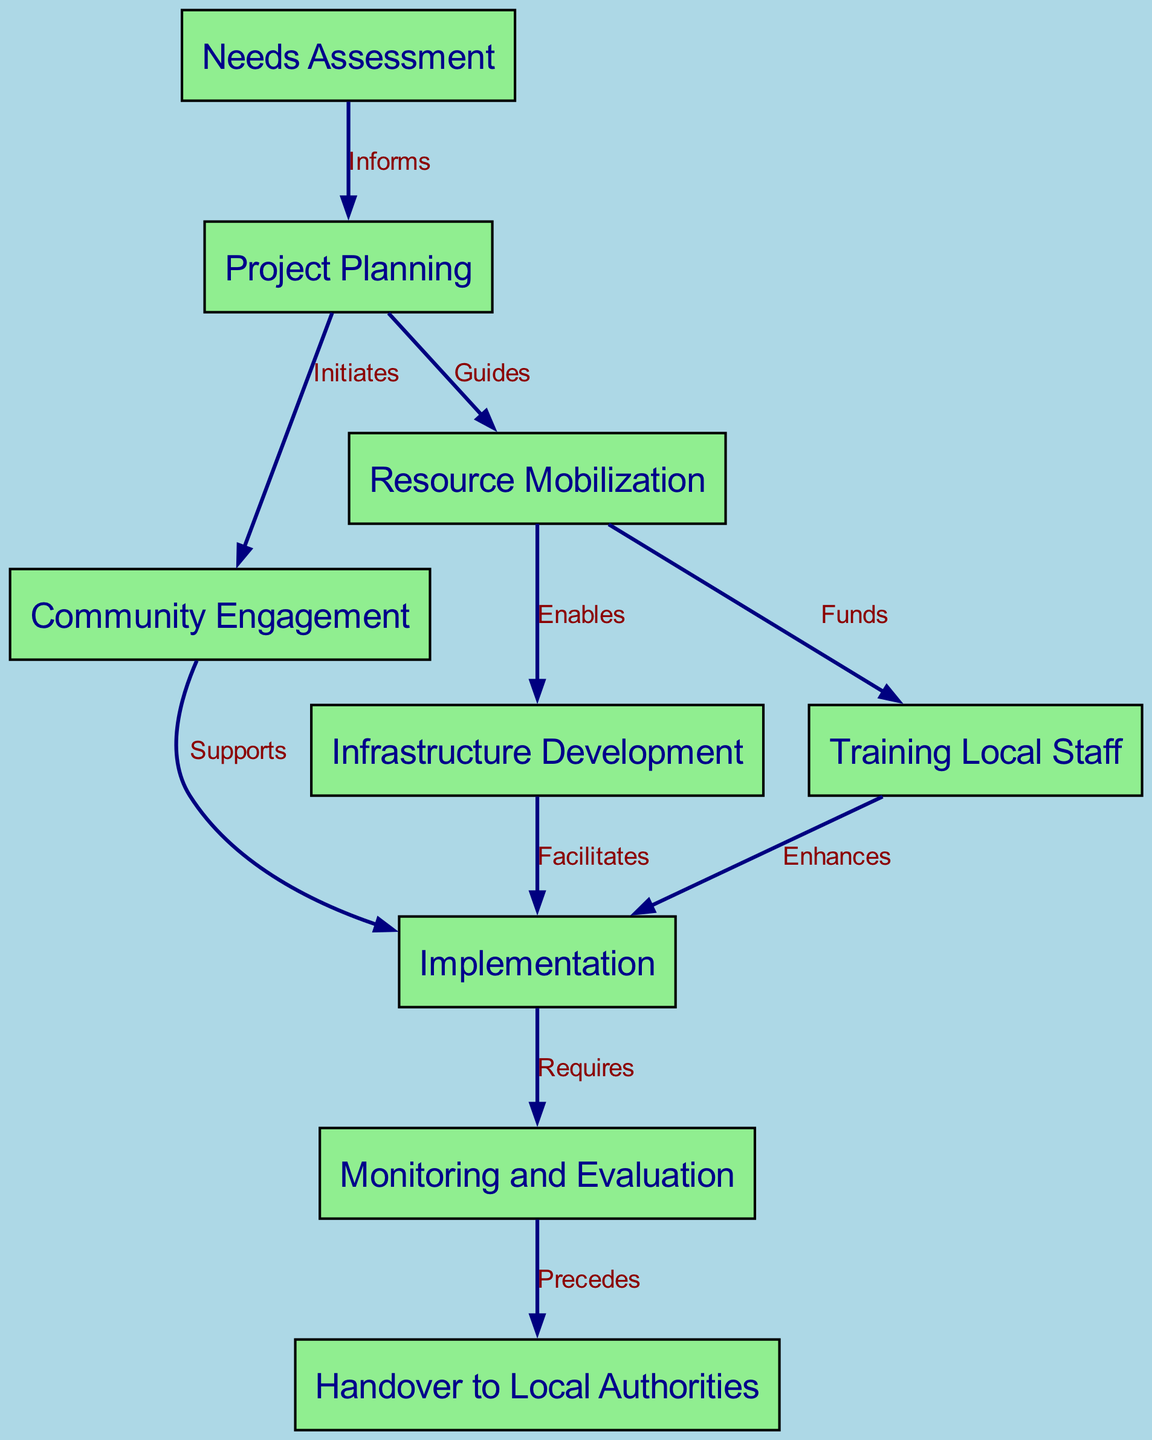What is the first stage in the water sanitation project? The first stage in the project is "Needs Assessment,” which is positioned at the top of the diagram.
Answer: Needs Assessment How many nodes are in the diagram? The diagram contains a total of nine nodes, each representing a stage in the water sanitation project.
Answer: 9 What relationship does "Community Engagement" have with "Implementation"? There is a directed edge from "Community Engagement" to "Implementation" labeled "Supports," indicating that community engagement supports the implementation stage.
Answer: Supports Which stage precedes the "Handover to Local Authorities"? The stage that precedes the "Handover to Local Authorities" is "Monitoring and Evaluation," as represented by the directed edge leading to the handover stage.
Answer: Monitoring and Evaluation What enables "Infrastructure Development"? "Resource Mobilization" enables "Infrastructure Development," as indicated by the edge connecting these two stages, which is labeled "Enables."
Answer: Resource Mobilization What is the final stage shown in the diagram? The final stage in the diagram is "Handover to Local Authorities," which is positioned at the bottom and is the last step in the project implementation flow.
Answer: Handover to Local Authorities How many edges are depicted in the graph? The diagram contains a total of ten edges, each representing a connection between various stages of the project.
Answer: 10 Which two stages fund the "Training Local Staff"? "Resource Mobilization" funds "Training Local Staff," as denoted by the edge connecting these stages, labeled "Funds."
Answer: Resource Mobilization What is the flow of the project after "Project Planning"? After "Project Planning," the flow proceeds to "Community Engagement" and "Resource Mobilization," indicating that both stages follow in the implementation sequence.
Answer: Community Engagement and Resource Mobilization 